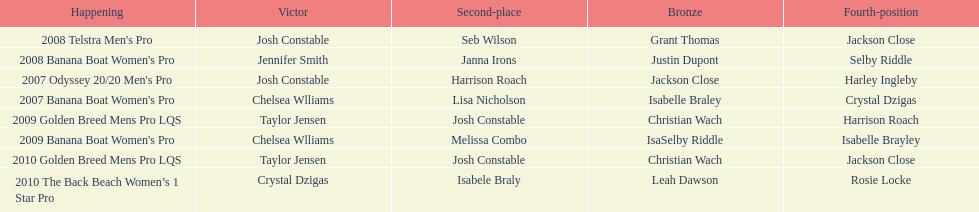At which event did taylor jensen first win? 2009 Golden Breed Mens Pro LQS. 